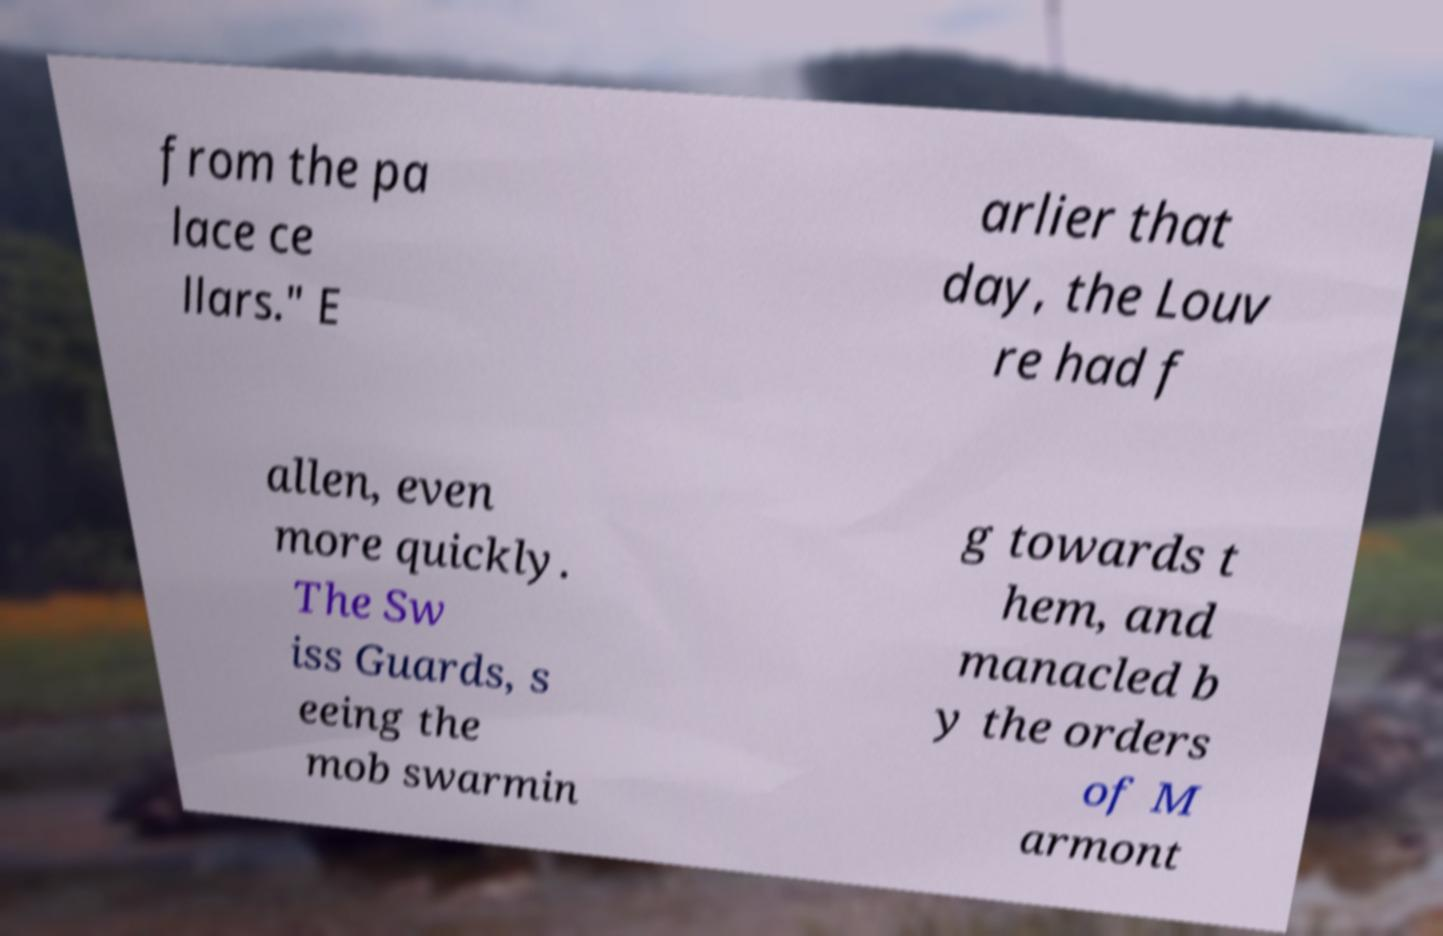Could you assist in decoding the text presented in this image and type it out clearly? from the pa lace ce llars." E arlier that day, the Louv re had f allen, even more quickly. The Sw iss Guards, s eeing the mob swarmin g towards t hem, and manacled b y the orders of M armont 